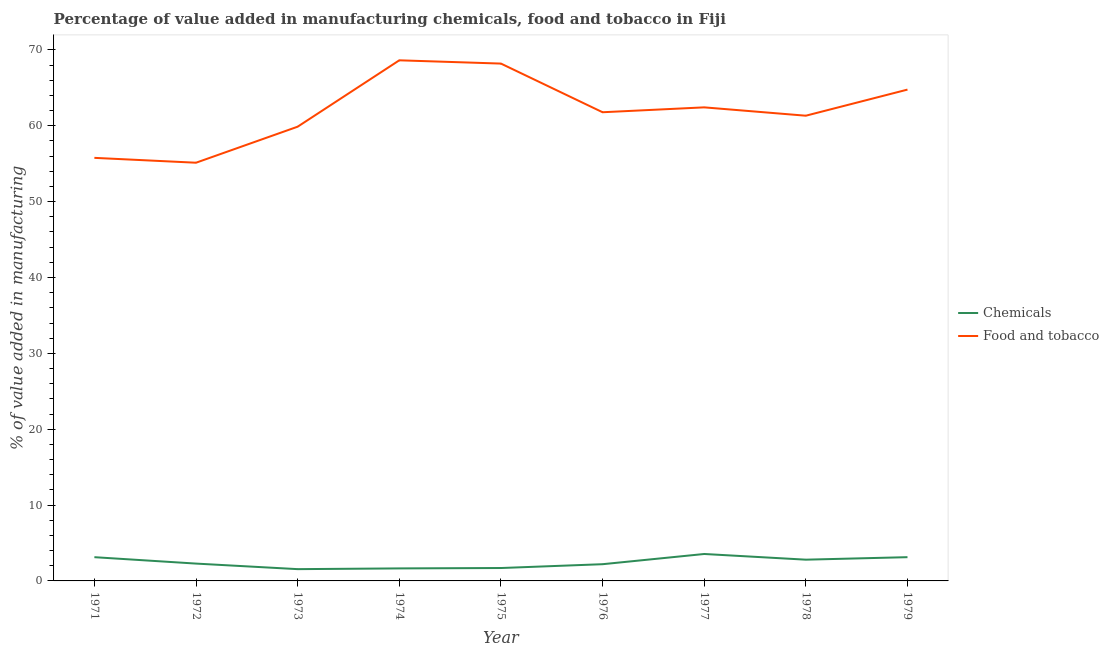Is the number of lines equal to the number of legend labels?
Your response must be concise. Yes. What is the value added by manufacturing food and tobacco in 1978?
Offer a terse response. 61.33. Across all years, what is the maximum value added by manufacturing food and tobacco?
Ensure brevity in your answer.  68.63. Across all years, what is the minimum value added by manufacturing food and tobacco?
Your response must be concise. 55.13. What is the total value added by manufacturing food and tobacco in the graph?
Offer a terse response. 557.91. What is the difference between the value added by  manufacturing chemicals in 1972 and that in 1978?
Your response must be concise. -0.52. What is the difference between the value added by manufacturing food and tobacco in 1979 and the value added by  manufacturing chemicals in 1973?
Offer a very short reply. 63.22. What is the average value added by  manufacturing chemicals per year?
Your response must be concise. 2.45. In the year 1974, what is the difference between the value added by manufacturing food and tobacco and value added by  manufacturing chemicals?
Offer a terse response. 66.98. What is the ratio of the value added by manufacturing food and tobacco in 1978 to that in 1979?
Keep it short and to the point. 0.95. Is the difference between the value added by manufacturing food and tobacco in 1973 and 1974 greater than the difference between the value added by  manufacturing chemicals in 1973 and 1974?
Ensure brevity in your answer.  No. What is the difference between the highest and the second highest value added by  manufacturing chemicals?
Your answer should be compact. 0.42. What is the difference between the highest and the lowest value added by  manufacturing chemicals?
Ensure brevity in your answer.  2. In how many years, is the value added by manufacturing food and tobacco greater than the average value added by manufacturing food and tobacco taken over all years?
Your answer should be compact. 4. Does the value added by  manufacturing chemicals monotonically increase over the years?
Offer a very short reply. No. Does the graph contain grids?
Your answer should be very brief. No. Where does the legend appear in the graph?
Ensure brevity in your answer.  Center right. How many legend labels are there?
Offer a very short reply. 2. How are the legend labels stacked?
Your answer should be very brief. Vertical. What is the title of the graph?
Offer a terse response. Percentage of value added in manufacturing chemicals, food and tobacco in Fiji. What is the label or title of the Y-axis?
Offer a very short reply. % of value added in manufacturing. What is the % of value added in manufacturing of Chemicals in 1971?
Give a very brief answer. 3.13. What is the % of value added in manufacturing of Food and tobacco in 1971?
Provide a succinct answer. 55.77. What is the % of value added in manufacturing of Chemicals in 1972?
Ensure brevity in your answer.  2.29. What is the % of value added in manufacturing of Food and tobacco in 1972?
Keep it short and to the point. 55.13. What is the % of value added in manufacturing of Chemicals in 1973?
Your answer should be compact. 1.55. What is the % of value added in manufacturing of Food and tobacco in 1973?
Make the answer very short. 59.88. What is the % of value added in manufacturing in Chemicals in 1974?
Ensure brevity in your answer.  1.65. What is the % of value added in manufacturing in Food and tobacco in 1974?
Provide a short and direct response. 68.63. What is the % of value added in manufacturing in Chemicals in 1975?
Offer a terse response. 1.7. What is the % of value added in manufacturing in Food and tobacco in 1975?
Offer a terse response. 68.2. What is the % of value added in manufacturing of Chemicals in 1976?
Your answer should be compact. 2.2. What is the % of value added in manufacturing of Food and tobacco in 1976?
Provide a succinct answer. 61.78. What is the % of value added in manufacturing in Chemicals in 1977?
Offer a terse response. 3.55. What is the % of value added in manufacturing of Food and tobacco in 1977?
Offer a very short reply. 62.43. What is the % of value added in manufacturing of Chemicals in 1978?
Provide a succinct answer. 2.8. What is the % of value added in manufacturing in Food and tobacco in 1978?
Give a very brief answer. 61.33. What is the % of value added in manufacturing in Chemicals in 1979?
Your answer should be very brief. 3.13. What is the % of value added in manufacturing of Food and tobacco in 1979?
Provide a short and direct response. 64.77. Across all years, what is the maximum % of value added in manufacturing of Chemicals?
Provide a short and direct response. 3.55. Across all years, what is the maximum % of value added in manufacturing of Food and tobacco?
Offer a terse response. 68.63. Across all years, what is the minimum % of value added in manufacturing of Chemicals?
Offer a terse response. 1.55. Across all years, what is the minimum % of value added in manufacturing of Food and tobacco?
Offer a terse response. 55.13. What is the total % of value added in manufacturing of Chemicals in the graph?
Your response must be concise. 22.01. What is the total % of value added in manufacturing of Food and tobacco in the graph?
Provide a succinct answer. 557.91. What is the difference between the % of value added in manufacturing in Chemicals in 1971 and that in 1972?
Provide a short and direct response. 0.84. What is the difference between the % of value added in manufacturing in Food and tobacco in 1971 and that in 1972?
Offer a terse response. 0.64. What is the difference between the % of value added in manufacturing in Chemicals in 1971 and that in 1973?
Give a very brief answer. 1.58. What is the difference between the % of value added in manufacturing in Food and tobacco in 1971 and that in 1973?
Make the answer very short. -4.11. What is the difference between the % of value added in manufacturing of Chemicals in 1971 and that in 1974?
Provide a short and direct response. 1.48. What is the difference between the % of value added in manufacturing in Food and tobacco in 1971 and that in 1974?
Provide a short and direct response. -12.86. What is the difference between the % of value added in manufacturing of Chemicals in 1971 and that in 1975?
Ensure brevity in your answer.  1.43. What is the difference between the % of value added in manufacturing of Food and tobacco in 1971 and that in 1975?
Offer a terse response. -12.43. What is the difference between the % of value added in manufacturing in Chemicals in 1971 and that in 1976?
Your response must be concise. 0.93. What is the difference between the % of value added in manufacturing in Food and tobacco in 1971 and that in 1976?
Offer a terse response. -6.01. What is the difference between the % of value added in manufacturing of Chemicals in 1971 and that in 1977?
Offer a terse response. -0.42. What is the difference between the % of value added in manufacturing in Food and tobacco in 1971 and that in 1977?
Offer a terse response. -6.66. What is the difference between the % of value added in manufacturing of Chemicals in 1971 and that in 1978?
Your answer should be very brief. 0.33. What is the difference between the % of value added in manufacturing in Food and tobacco in 1971 and that in 1978?
Offer a very short reply. -5.56. What is the difference between the % of value added in manufacturing of Chemicals in 1971 and that in 1979?
Offer a very short reply. -0. What is the difference between the % of value added in manufacturing of Food and tobacco in 1971 and that in 1979?
Provide a short and direct response. -9. What is the difference between the % of value added in manufacturing of Chemicals in 1972 and that in 1973?
Provide a short and direct response. 0.73. What is the difference between the % of value added in manufacturing in Food and tobacco in 1972 and that in 1973?
Make the answer very short. -4.75. What is the difference between the % of value added in manufacturing in Chemicals in 1972 and that in 1974?
Provide a succinct answer. 0.64. What is the difference between the % of value added in manufacturing of Food and tobacco in 1972 and that in 1974?
Your response must be concise. -13.5. What is the difference between the % of value added in manufacturing in Chemicals in 1972 and that in 1975?
Keep it short and to the point. 0.58. What is the difference between the % of value added in manufacturing of Food and tobacco in 1972 and that in 1975?
Provide a succinct answer. -13.07. What is the difference between the % of value added in manufacturing in Chemicals in 1972 and that in 1976?
Your answer should be very brief. 0.08. What is the difference between the % of value added in manufacturing of Food and tobacco in 1972 and that in 1976?
Offer a terse response. -6.65. What is the difference between the % of value added in manufacturing in Chemicals in 1972 and that in 1977?
Offer a terse response. -1.27. What is the difference between the % of value added in manufacturing of Food and tobacco in 1972 and that in 1977?
Offer a terse response. -7.3. What is the difference between the % of value added in manufacturing of Chemicals in 1972 and that in 1978?
Offer a terse response. -0.52. What is the difference between the % of value added in manufacturing of Food and tobacco in 1972 and that in 1978?
Provide a short and direct response. -6.2. What is the difference between the % of value added in manufacturing of Chemicals in 1972 and that in 1979?
Your answer should be compact. -0.85. What is the difference between the % of value added in manufacturing in Food and tobacco in 1972 and that in 1979?
Provide a short and direct response. -9.64. What is the difference between the % of value added in manufacturing in Chemicals in 1973 and that in 1974?
Offer a very short reply. -0.1. What is the difference between the % of value added in manufacturing of Food and tobacco in 1973 and that in 1974?
Make the answer very short. -8.75. What is the difference between the % of value added in manufacturing in Chemicals in 1973 and that in 1975?
Your response must be concise. -0.15. What is the difference between the % of value added in manufacturing of Food and tobacco in 1973 and that in 1975?
Ensure brevity in your answer.  -8.32. What is the difference between the % of value added in manufacturing in Chemicals in 1973 and that in 1976?
Provide a succinct answer. -0.65. What is the difference between the % of value added in manufacturing in Food and tobacco in 1973 and that in 1976?
Provide a succinct answer. -1.91. What is the difference between the % of value added in manufacturing in Chemicals in 1973 and that in 1977?
Give a very brief answer. -2. What is the difference between the % of value added in manufacturing in Food and tobacco in 1973 and that in 1977?
Give a very brief answer. -2.55. What is the difference between the % of value added in manufacturing of Chemicals in 1973 and that in 1978?
Offer a very short reply. -1.25. What is the difference between the % of value added in manufacturing in Food and tobacco in 1973 and that in 1978?
Ensure brevity in your answer.  -1.45. What is the difference between the % of value added in manufacturing in Chemicals in 1973 and that in 1979?
Provide a succinct answer. -1.58. What is the difference between the % of value added in manufacturing of Food and tobacco in 1973 and that in 1979?
Keep it short and to the point. -4.89. What is the difference between the % of value added in manufacturing of Chemicals in 1974 and that in 1975?
Provide a succinct answer. -0.05. What is the difference between the % of value added in manufacturing of Food and tobacco in 1974 and that in 1975?
Offer a very short reply. 0.43. What is the difference between the % of value added in manufacturing of Chemicals in 1974 and that in 1976?
Give a very brief answer. -0.55. What is the difference between the % of value added in manufacturing in Food and tobacco in 1974 and that in 1976?
Offer a very short reply. 6.85. What is the difference between the % of value added in manufacturing in Chemicals in 1974 and that in 1977?
Give a very brief answer. -1.9. What is the difference between the % of value added in manufacturing in Food and tobacco in 1974 and that in 1977?
Your answer should be very brief. 6.2. What is the difference between the % of value added in manufacturing of Chemicals in 1974 and that in 1978?
Offer a terse response. -1.15. What is the difference between the % of value added in manufacturing of Food and tobacco in 1974 and that in 1978?
Offer a terse response. 7.3. What is the difference between the % of value added in manufacturing in Chemicals in 1974 and that in 1979?
Provide a succinct answer. -1.48. What is the difference between the % of value added in manufacturing of Food and tobacco in 1974 and that in 1979?
Your response must be concise. 3.86. What is the difference between the % of value added in manufacturing in Chemicals in 1975 and that in 1976?
Ensure brevity in your answer.  -0.5. What is the difference between the % of value added in manufacturing of Food and tobacco in 1975 and that in 1976?
Provide a succinct answer. 6.42. What is the difference between the % of value added in manufacturing of Chemicals in 1975 and that in 1977?
Provide a succinct answer. -1.85. What is the difference between the % of value added in manufacturing of Food and tobacco in 1975 and that in 1977?
Give a very brief answer. 5.77. What is the difference between the % of value added in manufacturing in Chemicals in 1975 and that in 1978?
Offer a very short reply. -1.1. What is the difference between the % of value added in manufacturing in Food and tobacco in 1975 and that in 1978?
Provide a short and direct response. 6.87. What is the difference between the % of value added in manufacturing of Chemicals in 1975 and that in 1979?
Your answer should be very brief. -1.43. What is the difference between the % of value added in manufacturing of Food and tobacco in 1975 and that in 1979?
Provide a short and direct response. 3.43. What is the difference between the % of value added in manufacturing in Chemicals in 1976 and that in 1977?
Offer a very short reply. -1.35. What is the difference between the % of value added in manufacturing in Food and tobacco in 1976 and that in 1977?
Offer a terse response. -0.64. What is the difference between the % of value added in manufacturing in Chemicals in 1976 and that in 1978?
Offer a terse response. -0.6. What is the difference between the % of value added in manufacturing in Food and tobacco in 1976 and that in 1978?
Offer a very short reply. 0.46. What is the difference between the % of value added in manufacturing of Chemicals in 1976 and that in 1979?
Provide a short and direct response. -0.93. What is the difference between the % of value added in manufacturing in Food and tobacco in 1976 and that in 1979?
Give a very brief answer. -2.99. What is the difference between the % of value added in manufacturing in Chemicals in 1977 and that in 1978?
Your answer should be compact. 0.75. What is the difference between the % of value added in manufacturing of Food and tobacco in 1977 and that in 1978?
Provide a short and direct response. 1.1. What is the difference between the % of value added in manufacturing in Chemicals in 1977 and that in 1979?
Make the answer very short. 0.42. What is the difference between the % of value added in manufacturing of Food and tobacco in 1977 and that in 1979?
Offer a very short reply. -2.34. What is the difference between the % of value added in manufacturing in Chemicals in 1978 and that in 1979?
Keep it short and to the point. -0.33. What is the difference between the % of value added in manufacturing of Food and tobacco in 1978 and that in 1979?
Make the answer very short. -3.44. What is the difference between the % of value added in manufacturing of Chemicals in 1971 and the % of value added in manufacturing of Food and tobacco in 1972?
Provide a short and direct response. -52. What is the difference between the % of value added in manufacturing of Chemicals in 1971 and the % of value added in manufacturing of Food and tobacco in 1973?
Make the answer very short. -56.75. What is the difference between the % of value added in manufacturing of Chemicals in 1971 and the % of value added in manufacturing of Food and tobacco in 1974?
Your answer should be very brief. -65.5. What is the difference between the % of value added in manufacturing in Chemicals in 1971 and the % of value added in manufacturing in Food and tobacco in 1975?
Your response must be concise. -65.07. What is the difference between the % of value added in manufacturing in Chemicals in 1971 and the % of value added in manufacturing in Food and tobacco in 1976?
Provide a short and direct response. -58.65. What is the difference between the % of value added in manufacturing in Chemicals in 1971 and the % of value added in manufacturing in Food and tobacco in 1977?
Offer a terse response. -59.3. What is the difference between the % of value added in manufacturing in Chemicals in 1971 and the % of value added in manufacturing in Food and tobacco in 1978?
Provide a succinct answer. -58.2. What is the difference between the % of value added in manufacturing in Chemicals in 1971 and the % of value added in manufacturing in Food and tobacco in 1979?
Provide a short and direct response. -61.64. What is the difference between the % of value added in manufacturing in Chemicals in 1972 and the % of value added in manufacturing in Food and tobacco in 1973?
Make the answer very short. -57.59. What is the difference between the % of value added in manufacturing of Chemicals in 1972 and the % of value added in manufacturing of Food and tobacco in 1974?
Offer a very short reply. -66.34. What is the difference between the % of value added in manufacturing of Chemicals in 1972 and the % of value added in manufacturing of Food and tobacco in 1975?
Offer a terse response. -65.91. What is the difference between the % of value added in manufacturing of Chemicals in 1972 and the % of value added in manufacturing of Food and tobacco in 1976?
Offer a terse response. -59.5. What is the difference between the % of value added in manufacturing in Chemicals in 1972 and the % of value added in manufacturing in Food and tobacco in 1977?
Your answer should be compact. -60.14. What is the difference between the % of value added in manufacturing in Chemicals in 1972 and the % of value added in manufacturing in Food and tobacco in 1978?
Ensure brevity in your answer.  -59.04. What is the difference between the % of value added in manufacturing of Chemicals in 1972 and the % of value added in manufacturing of Food and tobacco in 1979?
Make the answer very short. -62.48. What is the difference between the % of value added in manufacturing in Chemicals in 1973 and the % of value added in manufacturing in Food and tobacco in 1974?
Provide a succinct answer. -67.07. What is the difference between the % of value added in manufacturing of Chemicals in 1973 and the % of value added in manufacturing of Food and tobacco in 1975?
Offer a terse response. -66.64. What is the difference between the % of value added in manufacturing of Chemicals in 1973 and the % of value added in manufacturing of Food and tobacco in 1976?
Keep it short and to the point. -60.23. What is the difference between the % of value added in manufacturing in Chemicals in 1973 and the % of value added in manufacturing in Food and tobacco in 1977?
Make the answer very short. -60.87. What is the difference between the % of value added in manufacturing in Chemicals in 1973 and the % of value added in manufacturing in Food and tobacco in 1978?
Offer a terse response. -59.77. What is the difference between the % of value added in manufacturing in Chemicals in 1973 and the % of value added in manufacturing in Food and tobacco in 1979?
Provide a short and direct response. -63.22. What is the difference between the % of value added in manufacturing in Chemicals in 1974 and the % of value added in manufacturing in Food and tobacco in 1975?
Your answer should be very brief. -66.55. What is the difference between the % of value added in manufacturing in Chemicals in 1974 and the % of value added in manufacturing in Food and tobacco in 1976?
Provide a short and direct response. -60.13. What is the difference between the % of value added in manufacturing in Chemicals in 1974 and the % of value added in manufacturing in Food and tobacco in 1977?
Your response must be concise. -60.78. What is the difference between the % of value added in manufacturing in Chemicals in 1974 and the % of value added in manufacturing in Food and tobacco in 1978?
Make the answer very short. -59.68. What is the difference between the % of value added in manufacturing of Chemicals in 1974 and the % of value added in manufacturing of Food and tobacco in 1979?
Provide a short and direct response. -63.12. What is the difference between the % of value added in manufacturing in Chemicals in 1975 and the % of value added in manufacturing in Food and tobacco in 1976?
Make the answer very short. -60.08. What is the difference between the % of value added in manufacturing of Chemicals in 1975 and the % of value added in manufacturing of Food and tobacco in 1977?
Your answer should be compact. -60.73. What is the difference between the % of value added in manufacturing in Chemicals in 1975 and the % of value added in manufacturing in Food and tobacco in 1978?
Offer a very short reply. -59.63. What is the difference between the % of value added in manufacturing in Chemicals in 1975 and the % of value added in manufacturing in Food and tobacco in 1979?
Give a very brief answer. -63.07. What is the difference between the % of value added in manufacturing in Chemicals in 1976 and the % of value added in manufacturing in Food and tobacco in 1977?
Offer a terse response. -60.22. What is the difference between the % of value added in manufacturing in Chemicals in 1976 and the % of value added in manufacturing in Food and tobacco in 1978?
Give a very brief answer. -59.12. What is the difference between the % of value added in manufacturing of Chemicals in 1976 and the % of value added in manufacturing of Food and tobacco in 1979?
Give a very brief answer. -62.57. What is the difference between the % of value added in manufacturing of Chemicals in 1977 and the % of value added in manufacturing of Food and tobacco in 1978?
Give a very brief answer. -57.78. What is the difference between the % of value added in manufacturing in Chemicals in 1977 and the % of value added in manufacturing in Food and tobacco in 1979?
Offer a very short reply. -61.22. What is the difference between the % of value added in manufacturing in Chemicals in 1978 and the % of value added in manufacturing in Food and tobacco in 1979?
Your answer should be very brief. -61.97. What is the average % of value added in manufacturing of Chemicals per year?
Give a very brief answer. 2.44. What is the average % of value added in manufacturing in Food and tobacco per year?
Provide a succinct answer. 61.99. In the year 1971, what is the difference between the % of value added in manufacturing of Chemicals and % of value added in manufacturing of Food and tobacco?
Make the answer very short. -52.64. In the year 1972, what is the difference between the % of value added in manufacturing of Chemicals and % of value added in manufacturing of Food and tobacco?
Offer a terse response. -52.84. In the year 1973, what is the difference between the % of value added in manufacturing of Chemicals and % of value added in manufacturing of Food and tobacco?
Provide a short and direct response. -58.32. In the year 1974, what is the difference between the % of value added in manufacturing in Chemicals and % of value added in manufacturing in Food and tobacco?
Give a very brief answer. -66.98. In the year 1975, what is the difference between the % of value added in manufacturing in Chemicals and % of value added in manufacturing in Food and tobacco?
Your response must be concise. -66.5. In the year 1976, what is the difference between the % of value added in manufacturing of Chemicals and % of value added in manufacturing of Food and tobacco?
Your answer should be very brief. -59.58. In the year 1977, what is the difference between the % of value added in manufacturing in Chemicals and % of value added in manufacturing in Food and tobacco?
Provide a short and direct response. -58.88. In the year 1978, what is the difference between the % of value added in manufacturing of Chemicals and % of value added in manufacturing of Food and tobacco?
Your answer should be very brief. -58.52. In the year 1979, what is the difference between the % of value added in manufacturing of Chemicals and % of value added in manufacturing of Food and tobacco?
Offer a terse response. -61.64. What is the ratio of the % of value added in manufacturing of Chemicals in 1971 to that in 1972?
Your answer should be compact. 1.37. What is the ratio of the % of value added in manufacturing in Food and tobacco in 1971 to that in 1972?
Ensure brevity in your answer.  1.01. What is the ratio of the % of value added in manufacturing in Chemicals in 1971 to that in 1973?
Your answer should be very brief. 2.01. What is the ratio of the % of value added in manufacturing of Food and tobacco in 1971 to that in 1973?
Make the answer very short. 0.93. What is the ratio of the % of value added in manufacturing in Chemicals in 1971 to that in 1974?
Ensure brevity in your answer.  1.9. What is the ratio of the % of value added in manufacturing in Food and tobacco in 1971 to that in 1974?
Give a very brief answer. 0.81. What is the ratio of the % of value added in manufacturing of Chemicals in 1971 to that in 1975?
Your answer should be very brief. 1.84. What is the ratio of the % of value added in manufacturing of Food and tobacco in 1971 to that in 1975?
Keep it short and to the point. 0.82. What is the ratio of the % of value added in manufacturing of Chemicals in 1971 to that in 1976?
Offer a terse response. 1.42. What is the ratio of the % of value added in manufacturing of Food and tobacco in 1971 to that in 1976?
Your response must be concise. 0.9. What is the ratio of the % of value added in manufacturing in Chemicals in 1971 to that in 1977?
Provide a short and direct response. 0.88. What is the ratio of the % of value added in manufacturing in Food and tobacco in 1971 to that in 1977?
Your answer should be very brief. 0.89. What is the ratio of the % of value added in manufacturing of Chemicals in 1971 to that in 1978?
Ensure brevity in your answer.  1.12. What is the ratio of the % of value added in manufacturing in Food and tobacco in 1971 to that in 1978?
Make the answer very short. 0.91. What is the ratio of the % of value added in manufacturing in Chemicals in 1971 to that in 1979?
Keep it short and to the point. 1. What is the ratio of the % of value added in manufacturing in Food and tobacco in 1971 to that in 1979?
Ensure brevity in your answer.  0.86. What is the ratio of the % of value added in manufacturing in Chemicals in 1972 to that in 1973?
Your answer should be compact. 1.47. What is the ratio of the % of value added in manufacturing in Food and tobacco in 1972 to that in 1973?
Your answer should be very brief. 0.92. What is the ratio of the % of value added in manufacturing in Chemicals in 1972 to that in 1974?
Make the answer very short. 1.39. What is the ratio of the % of value added in manufacturing in Food and tobacco in 1972 to that in 1974?
Ensure brevity in your answer.  0.8. What is the ratio of the % of value added in manufacturing of Chemicals in 1972 to that in 1975?
Offer a terse response. 1.34. What is the ratio of the % of value added in manufacturing of Food and tobacco in 1972 to that in 1975?
Give a very brief answer. 0.81. What is the ratio of the % of value added in manufacturing of Chemicals in 1972 to that in 1976?
Provide a succinct answer. 1.04. What is the ratio of the % of value added in manufacturing of Food and tobacco in 1972 to that in 1976?
Provide a succinct answer. 0.89. What is the ratio of the % of value added in manufacturing in Chemicals in 1972 to that in 1977?
Keep it short and to the point. 0.64. What is the ratio of the % of value added in manufacturing of Food and tobacco in 1972 to that in 1977?
Your answer should be very brief. 0.88. What is the ratio of the % of value added in manufacturing in Chemicals in 1972 to that in 1978?
Keep it short and to the point. 0.82. What is the ratio of the % of value added in manufacturing in Food and tobacco in 1972 to that in 1978?
Keep it short and to the point. 0.9. What is the ratio of the % of value added in manufacturing in Chemicals in 1972 to that in 1979?
Your answer should be very brief. 0.73. What is the ratio of the % of value added in manufacturing in Food and tobacco in 1972 to that in 1979?
Your answer should be very brief. 0.85. What is the ratio of the % of value added in manufacturing in Chemicals in 1973 to that in 1974?
Give a very brief answer. 0.94. What is the ratio of the % of value added in manufacturing in Food and tobacco in 1973 to that in 1974?
Offer a very short reply. 0.87. What is the ratio of the % of value added in manufacturing in Chemicals in 1973 to that in 1975?
Offer a very short reply. 0.91. What is the ratio of the % of value added in manufacturing in Food and tobacco in 1973 to that in 1975?
Your answer should be very brief. 0.88. What is the ratio of the % of value added in manufacturing of Chemicals in 1973 to that in 1976?
Offer a very short reply. 0.71. What is the ratio of the % of value added in manufacturing of Food and tobacco in 1973 to that in 1976?
Make the answer very short. 0.97. What is the ratio of the % of value added in manufacturing of Chemicals in 1973 to that in 1977?
Your answer should be compact. 0.44. What is the ratio of the % of value added in manufacturing in Food and tobacco in 1973 to that in 1977?
Offer a very short reply. 0.96. What is the ratio of the % of value added in manufacturing in Chemicals in 1973 to that in 1978?
Provide a short and direct response. 0.55. What is the ratio of the % of value added in manufacturing in Food and tobacco in 1973 to that in 1978?
Offer a very short reply. 0.98. What is the ratio of the % of value added in manufacturing in Chemicals in 1973 to that in 1979?
Your response must be concise. 0.5. What is the ratio of the % of value added in manufacturing of Food and tobacco in 1973 to that in 1979?
Make the answer very short. 0.92. What is the ratio of the % of value added in manufacturing of Chemicals in 1974 to that in 1975?
Provide a succinct answer. 0.97. What is the ratio of the % of value added in manufacturing in Chemicals in 1974 to that in 1976?
Provide a succinct answer. 0.75. What is the ratio of the % of value added in manufacturing in Food and tobacco in 1974 to that in 1976?
Your answer should be very brief. 1.11. What is the ratio of the % of value added in manufacturing in Chemicals in 1974 to that in 1977?
Ensure brevity in your answer.  0.46. What is the ratio of the % of value added in manufacturing of Food and tobacco in 1974 to that in 1977?
Offer a terse response. 1.1. What is the ratio of the % of value added in manufacturing of Chemicals in 1974 to that in 1978?
Ensure brevity in your answer.  0.59. What is the ratio of the % of value added in manufacturing of Food and tobacco in 1974 to that in 1978?
Offer a very short reply. 1.12. What is the ratio of the % of value added in manufacturing of Chemicals in 1974 to that in 1979?
Your response must be concise. 0.53. What is the ratio of the % of value added in manufacturing of Food and tobacco in 1974 to that in 1979?
Keep it short and to the point. 1.06. What is the ratio of the % of value added in manufacturing of Chemicals in 1975 to that in 1976?
Provide a short and direct response. 0.77. What is the ratio of the % of value added in manufacturing in Food and tobacco in 1975 to that in 1976?
Provide a short and direct response. 1.1. What is the ratio of the % of value added in manufacturing in Chemicals in 1975 to that in 1977?
Offer a terse response. 0.48. What is the ratio of the % of value added in manufacturing of Food and tobacco in 1975 to that in 1977?
Your answer should be compact. 1.09. What is the ratio of the % of value added in manufacturing of Chemicals in 1975 to that in 1978?
Offer a terse response. 0.61. What is the ratio of the % of value added in manufacturing of Food and tobacco in 1975 to that in 1978?
Your answer should be compact. 1.11. What is the ratio of the % of value added in manufacturing in Chemicals in 1975 to that in 1979?
Your answer should be compact. 0.54. What is the ratio of the % of value added in manufacturing in Food and tobacco in 1975 to that in 1979?
Your answer should be very brief. 1.05. What is the ratio of the % of value added in manufacturing in Chemicals in 1976 to that in 1977?
Offer a very short reply. 0.62. What is the ratio of the % of value added in manufacturing in Chemicals in 1976 to that in 1978?
Keep it short and to the point. 0.79. What is the ratio of the % of value added in manufacturing in Food and tobacco in 1976 to that in 1978?
Give a very brief answer. 1.01. What is the ratio of the % of value added in manufacturing in Chemicals in 1976 to that in 1979?
Make the answer very short. 0.7. What is the ratio of the % of value added in manufacturing of Food and tobacco in 1976 to that in 1979?
Give a very brief answer. 0.95. What is the ratio of the % of value added in manufacturing in Chemicals in 1977 to that in 1978?
Provide a short and direct response. 1.27. What is the ratio of the % of value added in manufacturing in Food and tobacco in 1977 to that in 1978?
Offer a terse response. 1.02. What is the ratio of the % of value added in manufacturing of Chemicals in 1977 to that in 1979?
Provide a succinct answer. 1.13. What is the ratio of the % of value added in manufacturing of Food and tobacco in 1977 to that in 1979?
Make the answer very short. 0.96. What is the ratio of the % of value added in manufacturing in Chemicals in 1978 to that in 1979?
Offer a very short reply. 0.9. What is the ratio of the % of value added in manufacturing of Food and tobacco in 1978 to that in 1979?
Your answer should be compact. 0.95. What is the difference between the highest and the second highest % of value added in manufacturing in Chemicals?
Give a very brief answer. 0.42. What is the difference between the highest and the second highest % of value added in manufacturing in Food and tobacco?
Your response must be concise. 0.43. What is the difference between the highest and the lowest % of value added in manufacturing in Chemicals?
Give a very brief answer. 2. What is the difference between the highest and the lowest % of value added in manufacturing in Food and tobacco?
Ensure brevity in your answer.  13.5. 